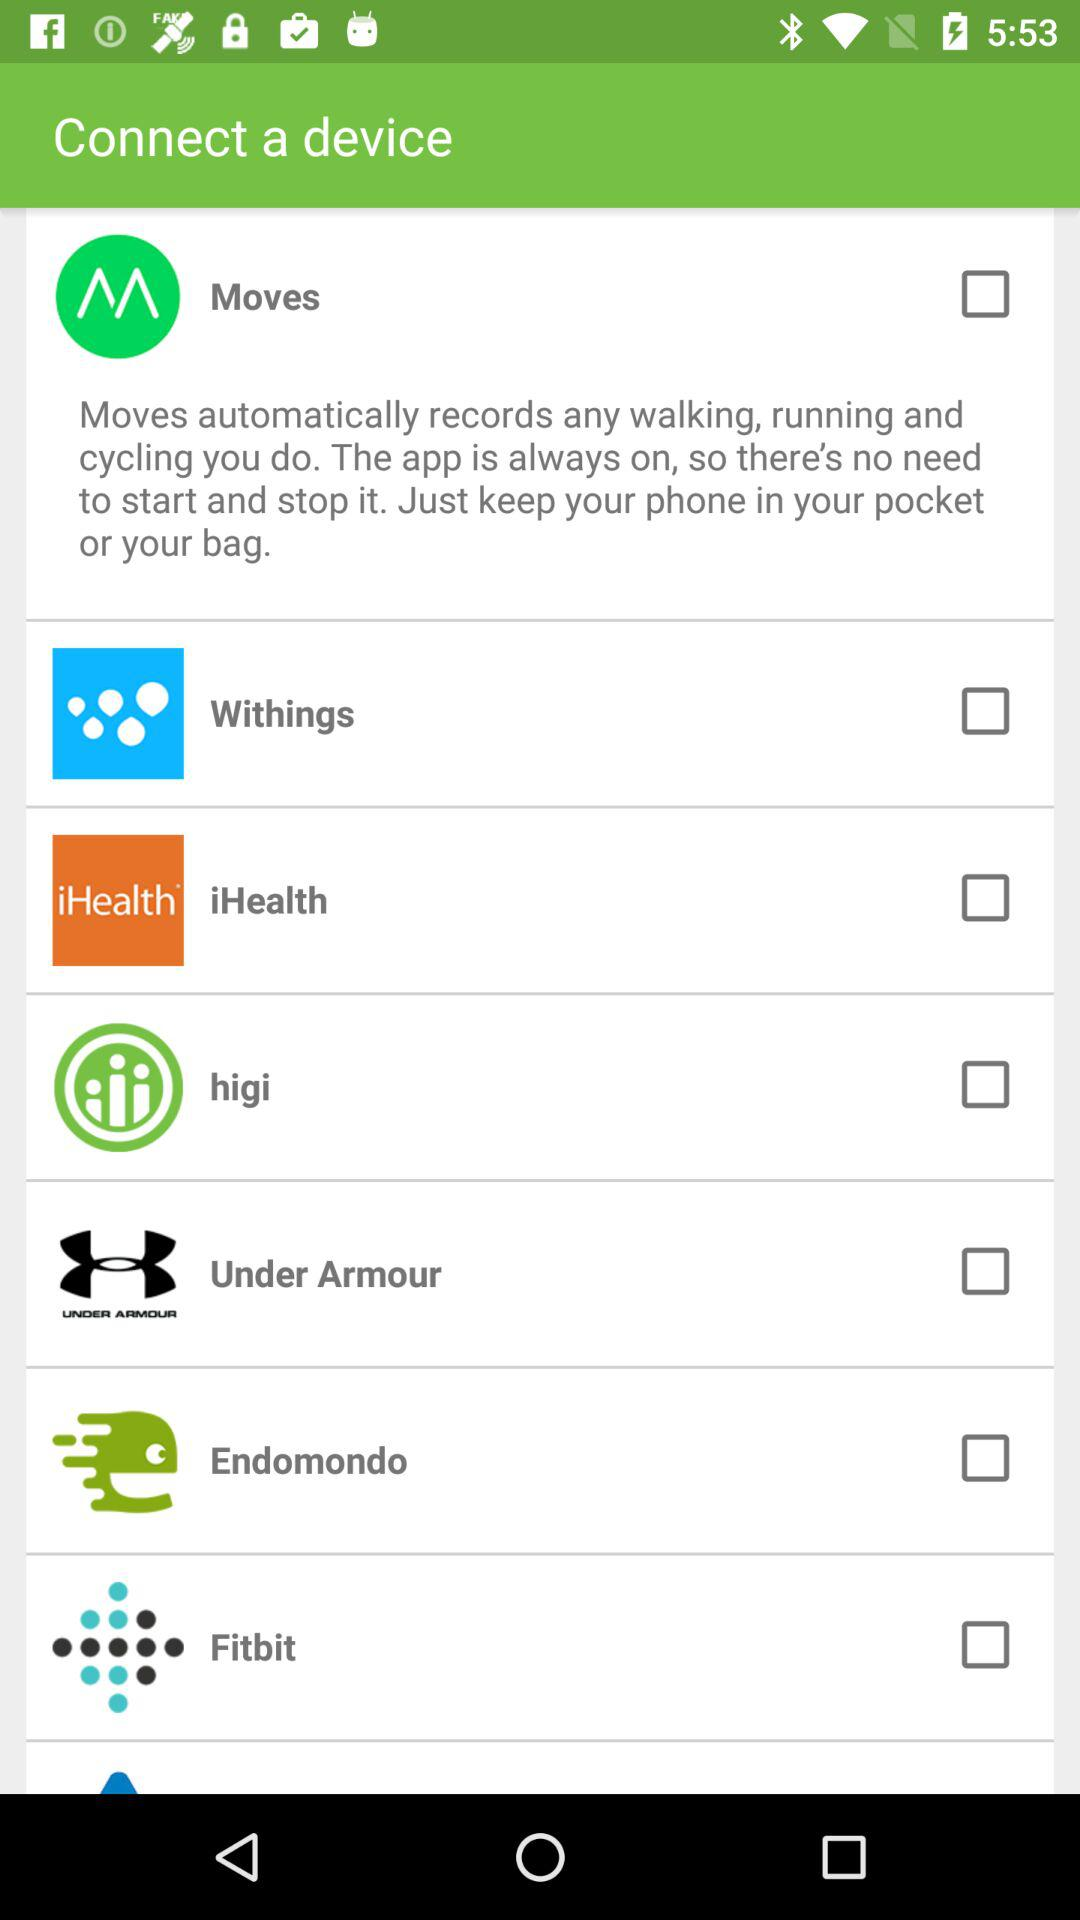What is the status of "Moves"? The status of "Moves" is "off". 